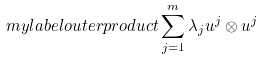<formula> <loc_0><loc_0><loc_500><loc_500>\ m y l a b e l { o u t e r p r o d u c t } \sum ^ { m } _ { j = 1 } \lambda _ { j } u ^ { j } \otimes u ^ { j }</formula> 